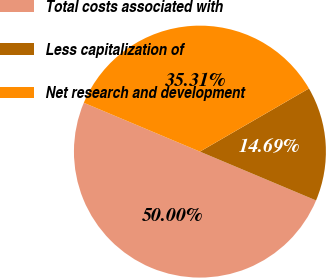<chart> <loc_0><loc_0><loc_500><loc_500><pie_chart><fcel>Total costs associated with<fcel>Less capitalization of<fcel>Net research and development<nl><fcel>50.0%<fcel>14.69%<fcel>35.31%<nl></chart> 